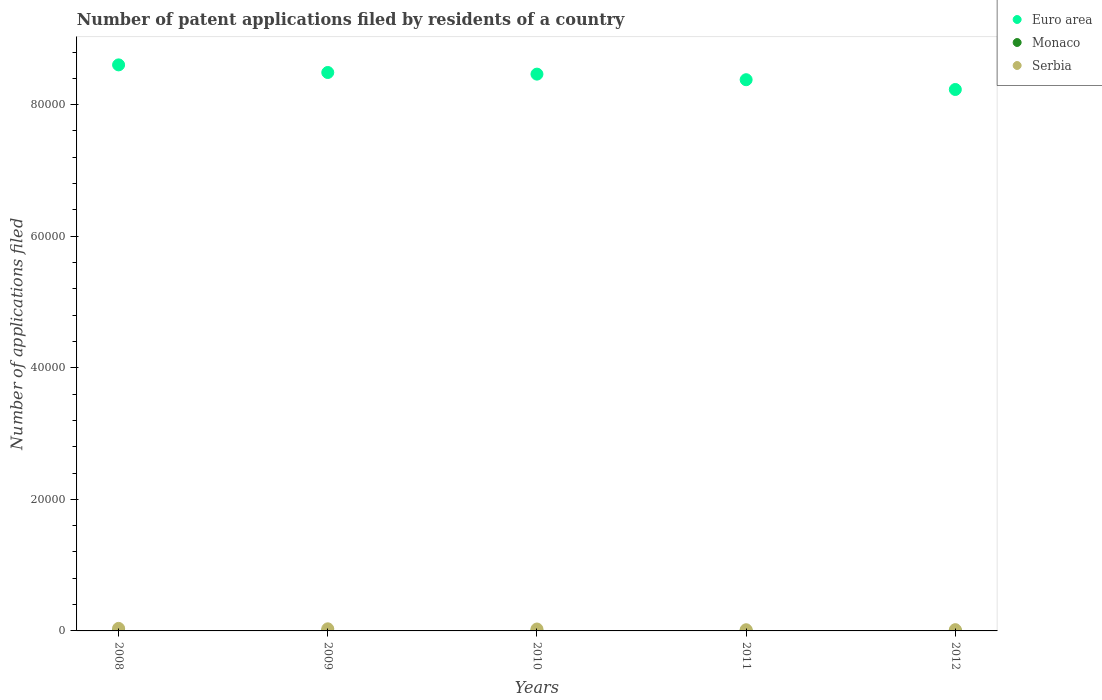What is the number of applications filed in Monaco in 2008?
Your answer should be very brief. 7. Across all years, what is the maximum number of applications filed in Serbia?
Offer a terse response. 386. Across all years, what is the minimum number of applications filed in Serbia?
Your answer should be compact. 180. In which year was the number of applications filed in Serbia minimum?
Your answer should be compact. 2011. What is the total number of applications filed in Euro area in the graph?
Your answer should be very brief. 4.22e+05. What is the difference between the number of applications filed in Monaco in 2008 and that in 2012?
Provide a short and direct response. 3. What is the difference between the number of applications filed in Euro area in 2011 and the number of applications filed in Serbia in 2009?
Ensure brevity in your answer.  8.35e+04. What is the average number of applications filed in Euro area per year?
Your answer should be very brief. 8.43e+04. In the year 2009, what is the difference between the number of applications filed in Monaco and number of applications filed in Euro area?
Offer a terse response. -8.49e+04. In how many years, is the number of applications filed in Serbia greater than 32000?
Offer a terse response. 0. What is the ratio of the number of applications filed in Euro area in 2009 to that in 2010?
Your answer should be very brief. 1. Is the number of applications filed in Euro area in 2008 less than that in 2011?
Your answer should be very brief. No. Is the difference between the number of applications filed in Monaco in 2008 and 2012 greater than the difference between the number of applications filed in Euro area in 2008 and 2012?
Provide a short and direct response. No. What is the difference between the highest and the second highest number of applications filed in Euro area?
Provide a short and direct response. 1158. What is the difference between the highest and the lowest number of applications filed in Euro area?
Offer a very short reply. 3741. In how many years, is the number of applications filed in Serbia greater than the average number of applications filed in Serbia taken over all years?
Offer a terse response. 3. Is the number of applications filed in Monaco strictly greater than the number of applications filed in Euro area over the years?
Offer a terse response. No. Is the number of applications filed in Monaco strictly less than the number of applications filed in Serbia over the years?
Make the answer very short. Yes. How many dotlines are there?
Make the answer very short. 3. Does the graph contain any zero values?
Offer a terse response. No. Does the graph contain grids?
Make the answer very short. No. How many legend labels are there?
Provide a succinct answer. 3. What is the title of the graph?
Your answer should be compact. Number of patent applications filed by residents of a country. What is the label or title of the X-axis?
Make the answer very short. Years. What is the label or title of the Y-axis?
Your answer should be very brief. Number of applications filed. What is the Number of applications filed in Euro area in 2008?
Offer a terse response. 8.60e+04. What is the Number of applications filed in Serbia in 2008?
Provide a succinct answer. 386. What is the Number of applications filed in Euro area in 2009?
Provide a short and direct response. 8.49e+04. What is the Number of applications filed in Monaco in 2009?
Ensure brevity in your answer.  3. What is the Number of applications filed in Serbia in 2009?
Make the answer very short. 319. What is the Number of applications filed in Euro area in 2010?
Provide a short and direct response. 8.46e+04. What is the Number of applications filed of Serbia in 2010?
Ensure brevity in your answer.  290. What is the Number of applications filed of Euro area in 2011?
Provide a short and direct response. 8.38e+04. What is the Number of applications filed in Serbia in 2011?
Your answer should be compact. 180. What is the Number of applications filed of Euro area in 2012?
Ensure brevity in your answer.  8.23e+04. What is the Number of applications filed of Serbia in 2012?
Give a very brief answer. 192. Across all years, what is the maximum Number of applications filed in Euro area?
Provide a short and direct response. 8.60e+04. Across all years, what is the maximum Number of applications filed of Monaco?
Your response must be concise. 7. Across all years, what is the maximum Number of applications filed in Serbia?
Offer a very short reply. 386. Across all years, what is the minimum Number of applications filed of Euro area?
Ensure brevity in your answer.  8.23e+04. Across all years, what is the minimum Number of applications filed of Serbia?
Your response must be concise. 180. What is the total Number of applications filed of Euro area in the graph?
Offer a terse response. 4.22e+05. What is the total Number of applications filed of Monaco in the graph?
Your answer should be very brief. 26. What is the total Number of applications filed of Serbia in the graph?
Ensure brevity in your answer.  1367. What is the difference between the Number of applications filed of Euro area in 2008 and that in 2009?
Ensure brevity in your answer.  1158. What is the difference between the Number of applications filed of Monaco in 2008 and that in 2009?
Offer a very short reply. 4. What is the difference between the Number of applications filed of Serbia in 2008 and that in 2009?
Give a very brief answer. 67. What is the difference between the Number of applications filed in Euro area in 2008 and that in 2010?
Provide a succinct answer. 1406. What is the difference between the Number of applications filed in Monaco in 2008 and that in 2010?
Offer a very short reply. 1. What is the difference between the Number of applications filed in Serbia in 2008 and that in 2010?
Make the answer very short. 96. What is the difference between the Number of applications filed of Euro area in 2008 and that in 2011?
Make the answer very short. 2255. What is the difference between the Number of applications filed in Serbia in 2008 and that in 2011?
Your answer should be very brief. 206. What is the difference between the Number of applications filed of Euro area in 2008 and that in 2012?
Offer a terse response. 3741. What is the difference between the Number of applications filed in Serbia in 2008 and that in 2012?
Your answer should be very brief. 194. What is the difference between the Number of applications filed in Euro area in 2009 and that in 2010?
Make the answer very short. 248. What is the difference between the Number of applications filed in Monaco in 2009 and that in 2010?
Your answer should be compact. -3. What is the difference between the Number of applications filed in Euro area in 2009 and that in 2011?
Make the answer very short. 1097. What is the difference between the Number of applications filed in Serbia in 2009 and that in 2011?
Make the answer very short. 139. What is the difference between the Number of applications filed of Euro area in 2009 and that in 2012?
Provide a short and direct response. 2583. What is the difference between the Number of applications filed of Monaco in 2009 and that in 2012?
Offer a very short reply. -1. What is the difference between the Number of applications filed of Serbia in 2009 and that in 2012?
Give a very brief answer. 127. What is the difference between the Number of applications filed of Euro area in 2010 and that in 2011?
Provide a succinct answer. 849. What is the difference between the Number of applications filed of Monaco in 2010 and that in 2011?
Provide a succinct answer. 0. What is the difference between the Number of applications filed of Serbia in 2010 and that in 2011?
Your response must be concise. 110. What is the difference between the Number of applications filed of Euro area in 2010 and that in 2012?
Your answer should be very brief. 2335. What is the difference between the Number of applications filed of Monaco in 2010 and that in 2012?
Keep it short and to the point. 2. What is the difference between the Number of applications filed in Serbia in 2010 and that in 2012?
Give a very brief answer. 98. What is the difference between the Number of applications filed of Euro area in 2011 and that in 2012?
Give a very brief answer. 1486. What is the difference between the Number of applications filed in Monaco in 2011 and that in 2012?
Your response must be concise. 2. What is the difference between the Number of applications filed in Serbia in 2011 and that in 2012?
Ensure brevity in your answer.  -12. What is the difference between the Number of applications filed of Euro area in 2008 and the Number of applications filed of Monaco in 2009?
Offer a terse response. 8.60e+04. What is the difference between the Number of applications filed of Euro area in 2008 and the Number of applications filed of Serbia in 2009?
Your response must be concise. 8.57e+04. What is the difference between the Number of applications filed in Monaco in 2008 and the Number of applications filed in Serbia in 2009?
Provide a succinct answer. -312. What is the difference between the Number of applications filed of Euro area in 2008 and the Number of applications filed of Monaco in 2010?
Make the answer very short. 8.60e+04. What is the difference between the Number of applications filed of Euro area in 2008 and the Number of applications filed of Serbia in 2010?
Offer a terse response. 8.58e+04. What is the difference between the Number of applications filed of Monaco in 2008 and the Number of applications filed of Serbia in 2010?
Keep it short and to the point. -283. What is the difference between the Number of applications filed in Euro area in 2008 and the Number of applications filed in Monaco in 2011?
Keep it short and to the point. 8.60e+04. What is the difference between the Number of applications filed in Euro area in 2008 and the Number of applications filed in Serbia in 2011?
Make the answer very short. 8.59e+04. What is the difference between the Number of applications filed in Monaco in 2008 and the Number of applications filed in Serbia in 2011?
Ensure brevity in your answer.  -173. What is the difference between the Number of applications filed in Euro area in 2008 and the Number of applications filed in Monaco in 2012?
Your answer should be very brief. 8.60e+04. What is the difference between the Number of applications filed of Euro area in 2008 and the Number of applications filed of Serbia in 2012?
Your response must be concise. 8.59e+04. What is the difference between the Number of applications filed of Monaco in 2008 and the Number of applications filed of Serbia in 2012?
Offer a terse response. -185. What is the difference between the Number of applications filed of Euro area in 2009 and the Number of applications filed of Monaco in 2010?
Your answer should be very brief. 8.49e+04. What is the difference between the Number of applications filed of Euro area in 2009 and the Number of applications filed of Serbia in 2010?
Your answer should be very brief. 8.46e+04. What is the difference between the Number of applications filed in Monaco in 2009 and the Number of applications filed in Serbia in 2010?
Provide a succinct answer. -287. What is the difference between the Number of applications filed in Euro area in 2009 and the Number of applications filed in Monaco in 2011?
Offer a terse response. 8.49e+04. What is the difference between the Number of applications filed in Euro area in 2009 and the Number of applications filed in Serbia in 2011?
Provide a short and direct response. 8.47e+04. What is the difference between the Number of applications filed in Monaco in 2009 and the Number of applications filed in Serbia in 2011?
Offer a very short reply. -177. What is the difference between the Number of applications filed of Euro area in 2009 and the Number of applications filed of Monaco in 2012?
Offer a very short reply. 8.49e+04. What is the difference between the Number of applications filed in Euro area in 2009 and the Number of applications filed in Serbia in 2012?
Offer a terse response. 8.47e+04. What is the difference between the Number of applications filed of Monaco in 2009 and the Number of applications filed of Serbia in 2012?
Your response must be concise. -189. What is the difference between the Number of applications filed of Euro area in 2010 and the Number of applications filed of Monaco in 2011?
Make the answer very short. 8.46e+04. What is the difference between the Number of applications filed of Euro area in 2010 and the Number of applications filed of Serbia in 2011?
Provide a succinct answer. 8.45e+04. What is the difference between the Number of applications filed in Monaco in 2010 and the Number of applications filed in Serbia in 2011?
Ensure brevity in your answer.  -174. What is the difference between the Number of applications filed in Euro area in 2010 and the Number of applications filed in Monaco in 2012?
Make the answer very short. 8.46e+04. What is the difference between the Number of applications filed of Euro area in 2010 and the Number of applications filed of Serbia in 2012?
Keep it short and to the point. 8.44e+04. What is the difference between the Number of applications filed in Monaco in 2010 and the Number of applications filed in Serbia in 2012?
Make the answer very short. -186. What is the difference between the Number of applications filed of Euro area in 2011 and the Number of applications filed of Monaco in 2012?
Your answer should be very brief. 8.38e+04. What is the difference between the Number of applications filed of Euro area in 2011 and the Number of applications filed of Serbia in 2012?
Your response must be concise. 8.36e+04. What is the difference between the Number of applications filed in Monaco in 2011 and the Number of applications filed in Serbia in 2012?
Provide a succinct answer. -186. What is the average Number of applications filed of Euro area per year?
Offer a very short reply. 8.43e+04. What is the average Number of applications filed of Serbia per year?
Keep it short and to the point. 273.4. In the year 2008, what is the difference between the Number of applications filed in Euro area and Number of applications filed in Monaco?
Give a very brief answer. 8.60e+04. In the year 2008, what is the difference between the Number of applications filed in Euro area and Number of applications filed in Serbia?
Make the answer very short. 8.57e+04. In the year 2008, what is the difference between the Number of applications filed of Monaco and Number of applications filed of Serbia?
Ensure brevity in your answer.  -379. In the year 2009, what is the difference between the Number of applications filed in Euro area and Number of applications filed in Monaco?
Make the answer very short. 8.49e+04. In the year 2009, what is the difference between the Number of applications filed in Euro area and Number of applications filed in Serbia?
Your response must be concise. 8.46e+04. In the year 2009, what is the difference between the Number of applications filed in Monaco and Number of applications filed in Serbia?
Make the answer very short. -316. In the year 2010, what is the difference between the Number of applications filed in Euro area and Number of applications filed in Monaco?
Your response must be concise. 8.46e+04. In the year 2010, what is the difference between the Number of applications filed of Euro area and Number of applications filed of Serbia?
Ensure brevity in your answer.  8.44e+04. In the year 2010, what is the difference between the Number of applications filed in Monaco and Number of applications filed in Serbia?
Ensure brevity in your answer.  -284. In the year 2011, what is the difference between the Number of applications filed of Euro area and Number of applications filed of Monaco?
Offer a terse response. 8.38e+04. In the year 2011, what is the difference between the Number of applications filed of Euro area and Number of applications filed of Serbia?
Your answer should be compact. 8.36e+04. In the year 2011, what is the difference between the Number of applications filed in Monaco and Number of applications filed in Serbia?
Your answer should be very brief. -174. In the year 2012, what is the difference between the Number of applications filed of Euro area and Number of applications filed of Monaco?
Provide a succinct answer. 8.23e+04. In the year 2012, what is the difference between the Number of applications filed of Euro area and Number of applications filed of Serbia?
Provide a succinct answer. 8.21e+04. In the year 2012, what is the difference between the Number of applications filed of Monaco and Number of applications filed of Serbia?
Keep it short and to the point. -188. What is the ratio of the Number of applications filed of Euro area in 2008 to that in 2009?
Offer a terse response. 1.01. What is the ratio of the Number of applications filed of Monaco in 2008 to that in 2009?
Provide a short and direct response. 2.33. What is the ratio of the Number of applications filed in Serbia in 2008 to that in 2009?
Your response must be concise. 1.21. What is the ratio of the Number of applications filed of Euro area in 2008 to that in 2010?
Provide a succinct answer. 1.02. What is the ratio of the Number of applications filed of Serbia in 2008 to that in 2010?
Keep it short and to the point. 1.33. What is the ratio of the Number of applications filed of Euro area in 2008 to that in 2011?
Your response must be concise. 1.03. What is the ratio of the Number of applications filed of Monaco in 2008 to that in 2011?
Keep it short and to the point. 1.17. What is the ratio of the Number of applications filed in Serbia in 2008 to that in 2011?
Your response must be concise. 2.14. What is the ratio of the Number of applications filed of Euro area in 2008 to that in 2012?
Keep it short and to the point. 1.05. What is the ratio of the Number of applications filed in Monaco in 2008 to that in 2012?
Your answer should be very brief. 1.75. What is the ratio of the Number of applications filed of Serbia in 2008 to that in 2012?
Your response must be concise. 2.01. What is the ratio of the Number of applications filed in Monaco in 2009 to that in 2010?
Offer a terse response. 0.5. What is the ratio of the Number of applications filed in Serbia in 2009 to that in 2010?
Your response must be concise. 1.1. What is the ratio of the Number of applications filed of Euro area in 2009 to that in 2011?
Provide a short and direct response. 1.01. What is the ratio of the Number of applications filed in Serbia in 2009 to that in 2011?
Ensure brevity in your answer.  1.77. What is the ratio of the Number of applications filed of Euro area in 2009 to that in 2012?
Provide a short and direct response. 1.03. What is the ratio of the Number of applications filed of Monaco in 2009 to that in 2012?
Provide a succinct answer. 0.75. What is the ratio of the Number of applications filed of Serbia in 2009 to that in 2012?
Offer a terse response. 1.66. What is the ratio of the Number of applications filed in Monaco in 2010 to that in 2011?
Provide a succinct answer. 1. What is the ratio of the Number of applications filed of Serbia in 2010 to that in 2011?
Offer a terse response. 1.61. What is the ratio of the Number of applications filed in Euro area in 2010 to that in 2012?
Your answer should be compact. 1.03. What is the ratio of the Number of applications filed in Serbia in 2010 to that in 2012?
Your answer should be compact. 1.51. What is the ratio of the Number of applications filed in Euro area in 2011 to that in 2012?
Ensure brevity in your answer.  1.02. What is the difference between the highest and the second highest Number of applications filed in Euro area?
Offer a terse response. 1158. What is the difference between the highest and the lowest Number of applications filed of Euro area?
Make the answer very short. 3741. What is the difference between the highest and the lowest Number of applications filed in Monaco?
Give a very brief answer. 4. What is the difference between the highest and the lowest Number of applications filed of Serbia?
Your response must be concise. 206. 